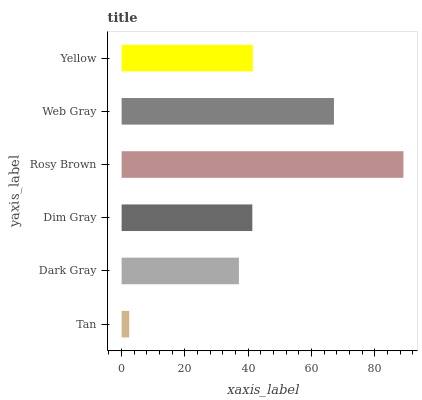Is Tan the minimum?
Answer yes or no. Yes. Is Rosy Brown the maximum?
Answer yes or no. Yes. Is Dark Gray the minimum?
Answer yes or no. No. Is Dark Gray the maximum?
Answer yes or no. No. Is Dark Gray greater than Tan?
Answer yes or no. Yes. Is Tan less than Dark Gray?
Answer yes or no. Yes. Is Tan greater than Dark Gray?
Answer yes or no. No. Is Dark Gray less than Tan?
Answer yes or no. No. Is Yellow the high median?
Answer yes or no. Yes. Is Dim Gray the low median?
Answer yes or no. Yes. Is Dim Gray the high median?
Answer yes or no. No. Is Dark Gray the low median?
Answer yes or no. No. 